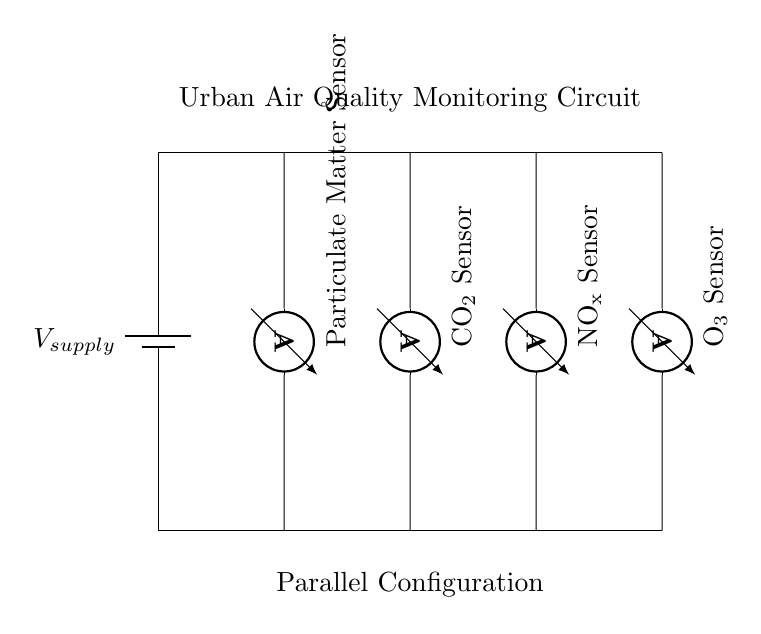What type of circuit is shown? The circuit configuration is parallel, indicated by the multiple branches connected to the same voltage supply, allowing each instrument to function independently.
Answer: Parallel How many sensors are present in the circuit? The circuit diagram shows four sensors, each represented by an ammeter symbol, indicating they are measuring different air quality parameters.
Answer: Four What is the total voltage supplied to the circuit? The total voltage supplied is uniform across all branches, represented by the battery in the diagram, signifying that each sensor receives the same voltage.
Answer: V supply Which sensor measures particulate matter? The sensor for particulate matter is the first one listed in the diagram, located at the leftmost branch of the parallel configuration, clearly labeled as such.
Answer: Particulate Matter Sensor Why is a parallel configuration used for these sensors? A parallel configuration ensures that each sensor operates independently; if one sensor fails, the others continue functioning, which is crucial for consistent air quality monitoring.
Answer: Independence What do the labels on the ammeters represent? The labels indicate different types of air quality parameters each sensor measures, such as particulate matter, CO2, NOx, and ozone, essential for comprehensive environmental data.
Answer: Air quality parameters 